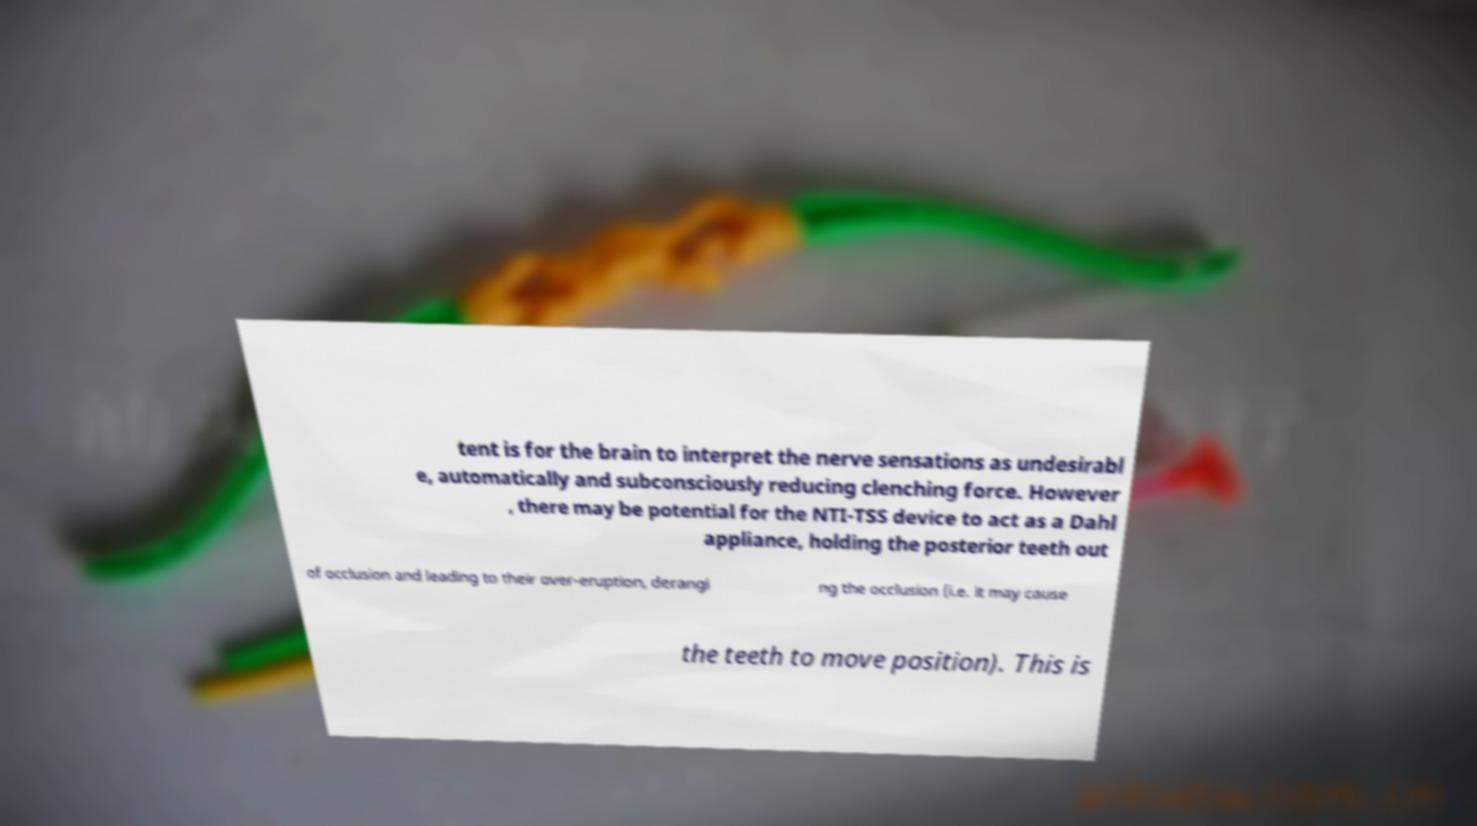Could you extract and type out the text from this image? tent is for the brain to interpret the nerve sensations as undesirabl e, automatically and subconsciously reducing clenching force. However , there may be potential for the NTI-TSS device to act as a Dahl appliance, holding the posterior teeth out of occlusion and leading to their over-eruption, derangi ng the occlusion (i.e. it may cause the teeth to move position). This is 